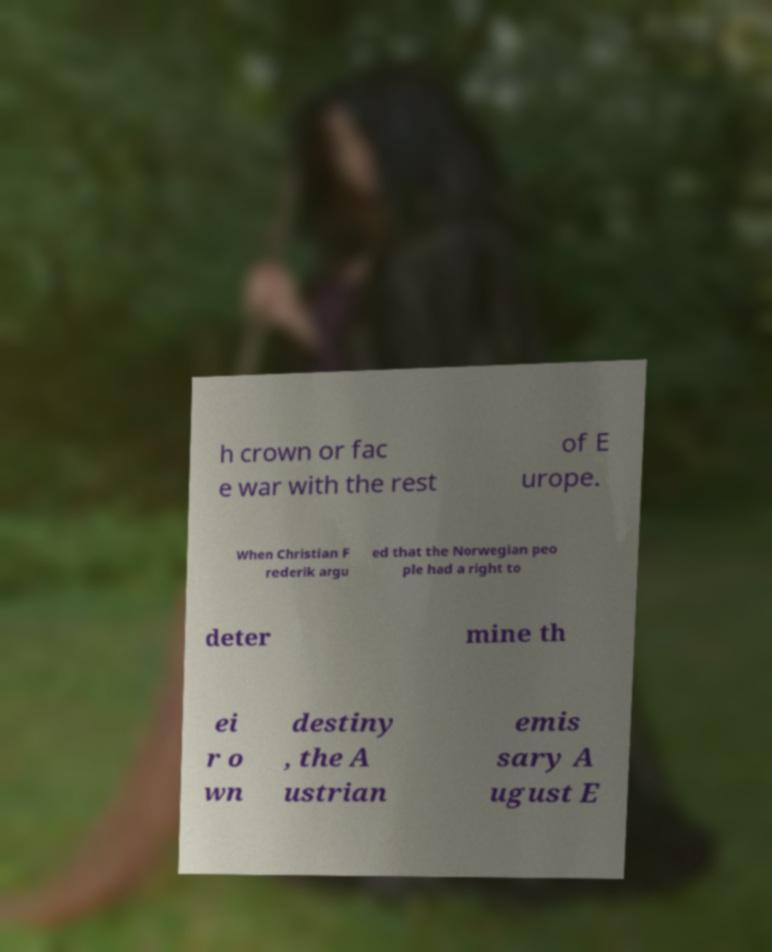Could you assist in decoding the text presented in this image and type it out clearly? h crown or fac e war with the rest of E urope. When Christian F rederik argu ed that the Norwegian peo ple had a right to deter mine th ei r o wn destiny , the A ustrian emis sary A ugust E 